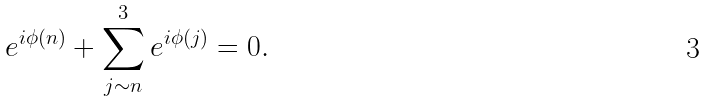<formula> <loc_0><loc_0><loc_500><loc_500>e ^ { i \phi ( n ) } + \sum _ { j \sim n } ^ { 3 } e ^ { i \phi ( j ) } = 0 .</formula> 